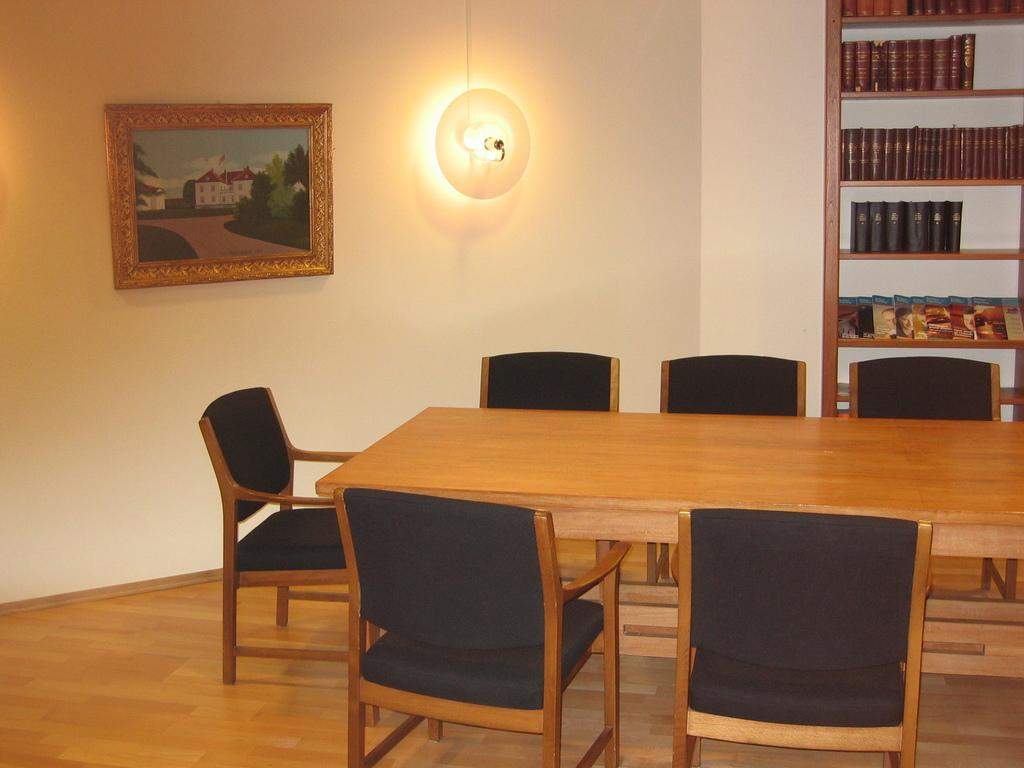What type of furniture is present in the image? There is a table and chairs in the image. What decorative item can be seen in the image? There is a photo frame in the image. What source of light is visible in the image? There is a lamp in the image. Where are the photo frame and lamp located in the image? The photo frame and lamp are attached to the wall. What type of items are stored in the racks in the image? The books are kept in racks in the image. What part of the room can be seen in the image? The floor is visible in the image. How many slaves are visible in the image? There are no slaves present in the image. What type of library is shown in the image? The image does not depict a library; it shows a room with a table, chairs, and other items. 